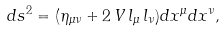Convert formula to latex. <formula><loc_0><loc_0><loc_500><loc_500>d s ^ { 2 } = ( { \eta _ { \mu \nu } } + 2 \, V \, { l _ { \mu } } \, { l _ { \nu } } ) d x ^ { \mu } d x ^ { \nu } ,</formula> 